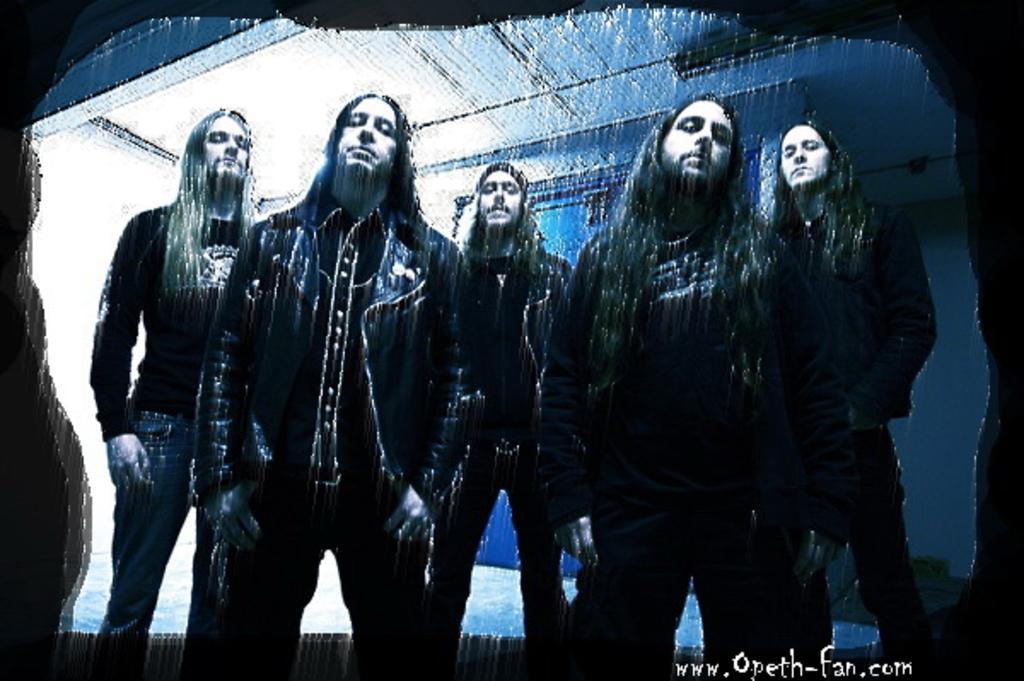How would you summarize this image in a sentence or two? This is an edited image. In the center of the image we can see five men are standing and wearing jackets. In the background of the image we can see the wall, board, roof and floor. In the bottom right corner we can see the text. 